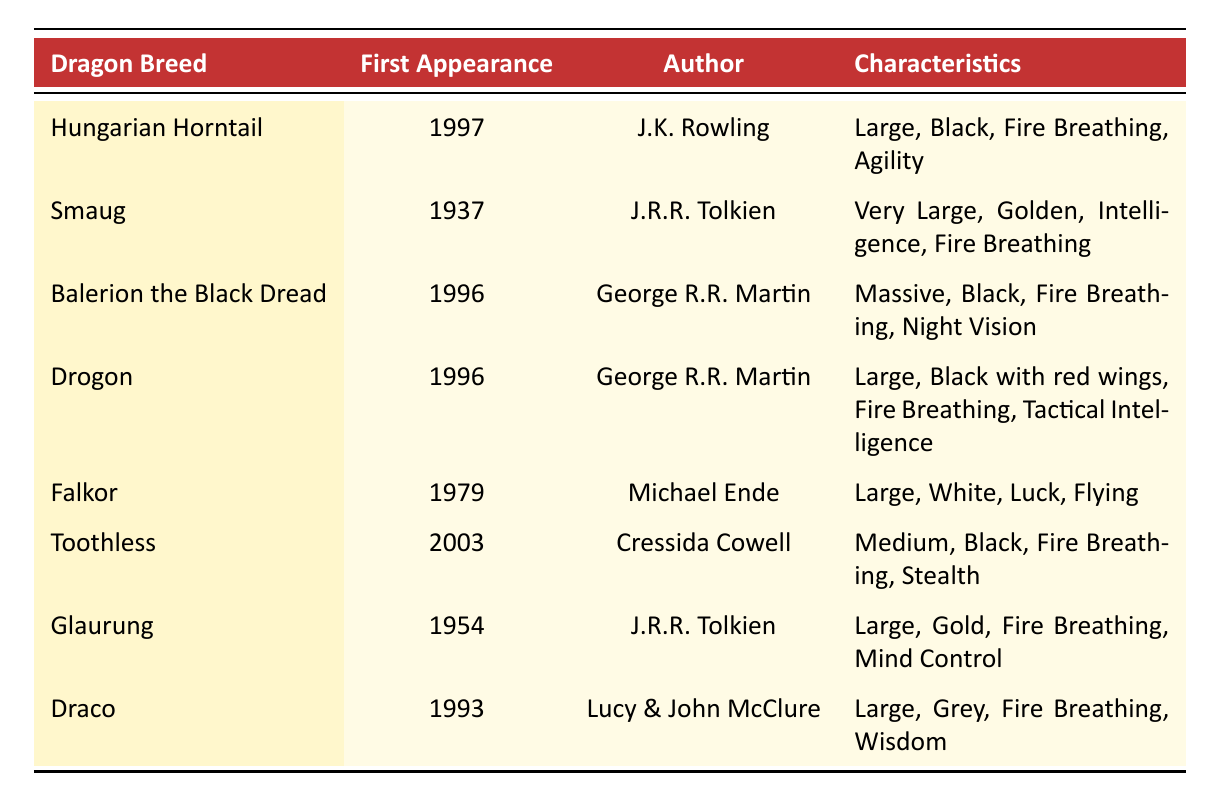What dragon breed first appeared in 1937? Referring to the table, Smaug is listed under "First Appearance" as 1937.
Answer: Smaug Which dragon breed is known for its abilities of Luck and Flying? By examining the "Characteristics" column, Falkor is identified as having abilities of Luck and Flying.
Answer: Falkor How many dragon breeds have fire breathing as one of their abilities? Upon counting the breeds listed, Hungarian Horntail, Smaug, Balerion the Black Dread, Drogon, Glaurung, Draco, and Toothless all have fire breathing as an ability, making a total of 7.
Answer: 7 What is the size of the dragon named Toothless? The table indicates that Toothless is classified as "Medium" in size.
Answer: Medium Which author created the dragon breed Balerion the Black Dread? The table shows that Balerion the Black Dread was created by George R.R. Martin.
Answer: George R.R. Martin Is there a dragon breed that first appeared after the year 2000? Looking at the "First Appearance" column, Toothless is the only breed that first appeared in 2003, confirming that yes, there is such a breed.
Answer: Yes What is the color of the dragon Glaurung? The "Characteristics" section states that Glaurung is colored Gold.
Answer: Gold Which dragon breed has the ability to control minds? From the table, it can be inferred that Glaurung is the only dragon breed listed with the ability of Mind Control.
Answer: Glaurung Which two dragon breeds were first introduced in the same year? The table shows that Balerion the Black Dread and Drogon both made their first appearances in 1996, thus they were introduced in the same year.
Answer: Balerion the Black Dread and Drogon What is the average first appearance year of the dragon breeds listed? Calculating the average: (1997 + 1937 + 1996 + 1996 + 1979 + 2003 + 1954 + 1993) / 8 = 1995.875. Rounding, the average first appearance year is approximately 1996.
Answer: 1996 